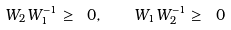Convert formula to latex. <formula><loc_0><loc_0><loc_500><loc_500>W _ { 2 } W _ { 1 } ^ { - 1 } \geq \ 0 , \quad W _ { 1 } W _ { 2 } ^ { - 1 } \geq \ 0</formula> 